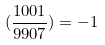<formula> <loc_0><loc_0><loc_500><loc_500>( \frac { 1 0 0 1 } { 9 9 0 7 } ) = - 1</formula> 